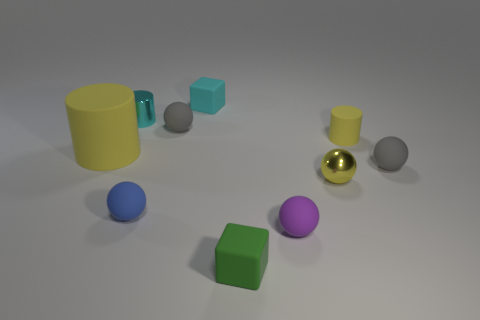Are there any tiny gray objects that have the same shape as the purple rubber thing?
Make the answer very short. Yes. The green thing that is the same size as the cyan matte object is what shape?
Make the answer very short. Cube. Is the number of large yellow rubber cylinders on the right side of the shiny cylinder the same as the number of tiny rubber objects left of the green object?
Give a very brief answer. No. There is a blue matte ball in front of the small gray ball behind the large yellow matte thing; what is its size?
Provide a short and direct response. Small. Is there a blue rubber sphere that has the same size as the blue thing?
Offer a very short reply. No. What color is the tiny cylinder that is the same material as the tiny purple ball?
Keep it short and to the point. Yellow. Is the number of tiny green rubber objects less than the number of small gray matte spheres?
Your answer should be very brief. Yes. There is a yellow object that is right of the tiny purple rubber sphere and behind the metal ball; what material is it?
Your response must be concise. Rubber. There is a rubber cylinder on the right side of the purple matte sphere; is there a tiny gray thing that is in front of it?
Provide a short and direct response. Yes. What number of rubber blocks have the same color as the tiny rubber cylinder?
Provide a short and direct response. 0. 